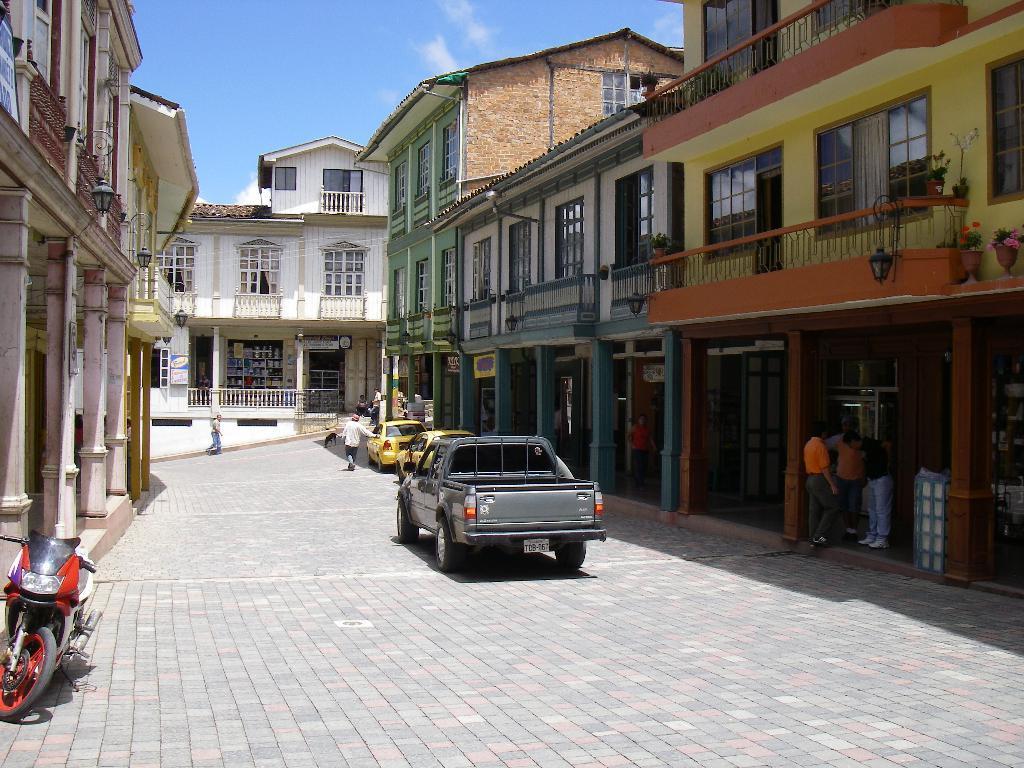What is the main feature of the image? There is a road in the image. What is happening on the road? There are vehicles on the road. Are there any people present in the image? Yes, there are people standing near the road. What can be seen on both sides of the road? There are buildings on both sides of the road. What is visible in the background of the image? The sky is visible in the background of the image. Can you see a wave crashing on the shore in the image? No, there is no wave or shore present in the image; it features a road with vehicles, people, and buildings. What type of quince is being used to decorate the buildings in the image? There is no quince present in the image; it features a road with vehicles, people, and buildings. 